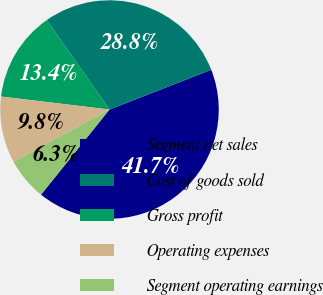<chart> <loc_0><loc_0><loc_500><loc_500><pie_chart><fcel>Segment net sales<fcel>Cost of goods sold<fcel>Gross profit<fcel>Operating expenses<fcel>Segment operating earnings<nl><fcel>41.7%<fcel>28.8%<fcel>13.38%<fcel>9.83%<fcel>6.29%<nl></chart> 